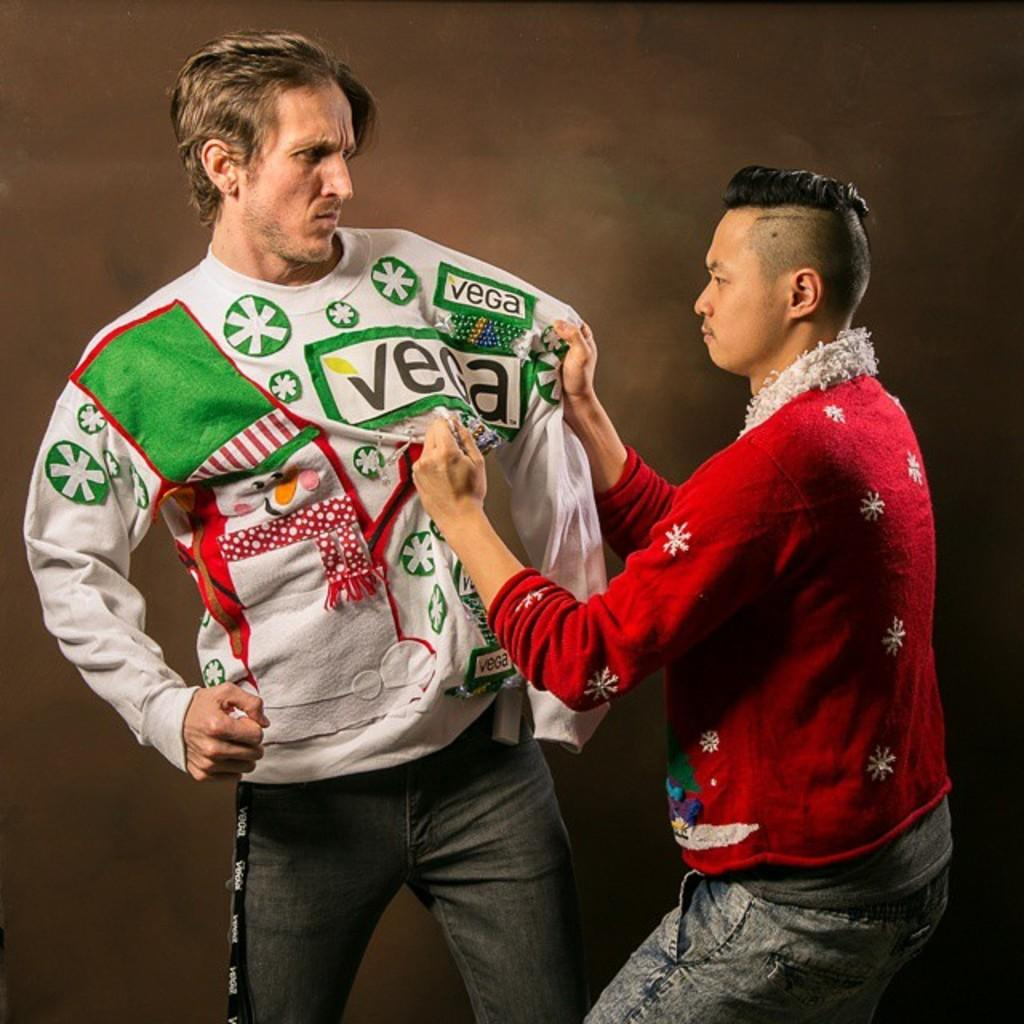<image>
Give a short and clear explanation of the subsequent image. A man is pulling on another mans sweater that has the word Vega on it. 